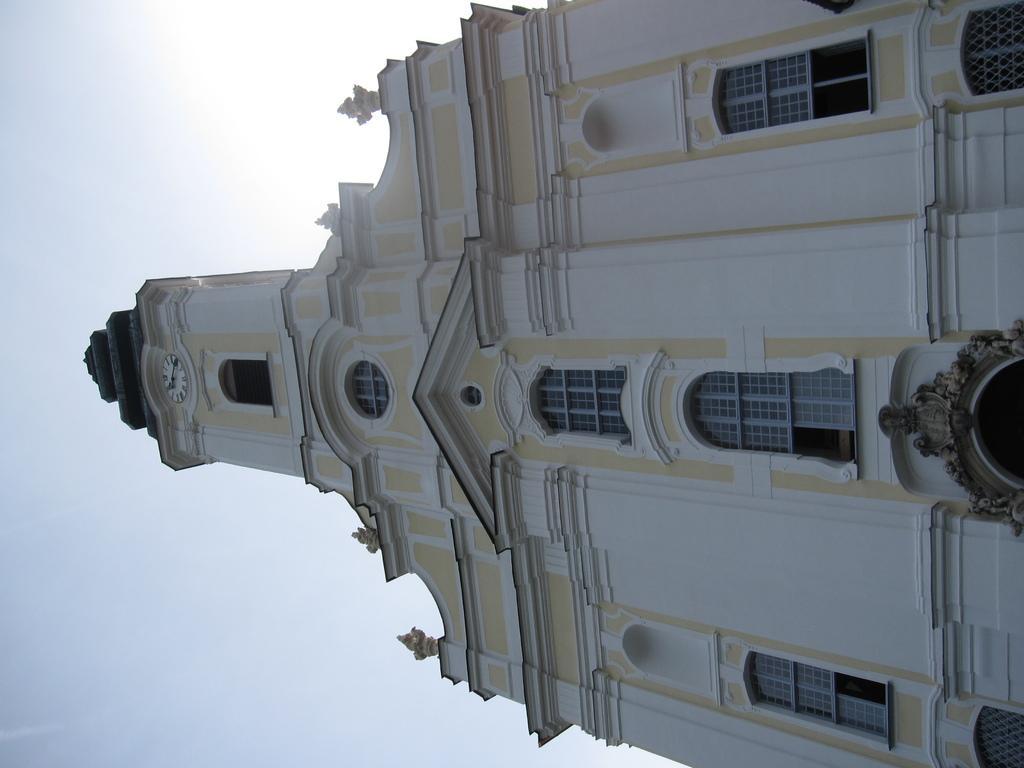Describe this image in one or two sentences. There is a building with windows, arches and a clock. In the background it is sky. 